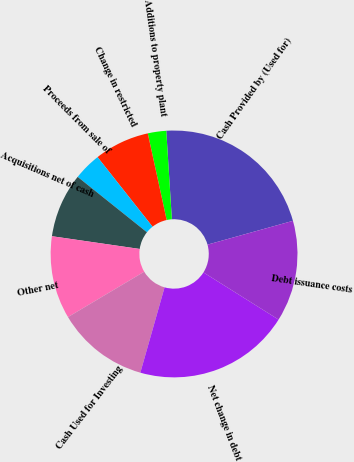Convert chart to OTSL. <chart><loc_0><loc_0><loc_500><loc_500><pie_chart><fcel>Cash Provided by (Used for)<fcel>Additions to property plant<fcel>Change in restricted<fcel>Proceeds from sale of<fcel>Acquisitions net of cash<fcel>Other net<fcel>Cash Used for Investing<fcel>Net change in debt<fcel>Debt issuance costs<nl><fcel>21.68%<fcel>2.41%<fcel>7.23%<fcel>3.62%<fcel>8.44%<fcel>10.84%<fcel>12.05%<fcel>20.48%<fcel>13.25%<nl></chart> 